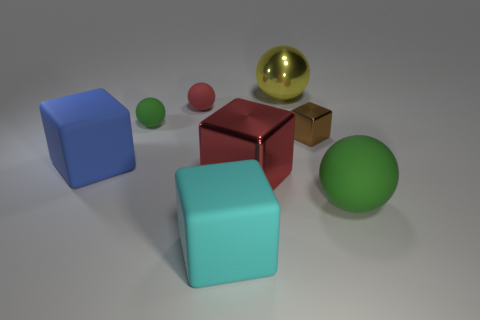Add 1 big blue things. How many objects exist? 9 Subtract all red matte balls. How many balls are left? 3 Subtract all yellow cubes. How many green balls are left? 2 Subtract 2 balls. How many balls are left? 2 Subtract all red blocks. How many blocks are left? 3 Subtract all red balls. Subtract all cyan cylinders. How many balls are left? 3 Add 8 tiny red things. How many tiny red things exist? 9 Subtract 0 purple cylinders. How many objects are left? 8 Subtract all purple blocks. Subtract all large cyan blocks. How many objects are left? 7 Add 4 large green balls. How many large green balls are left? 5 